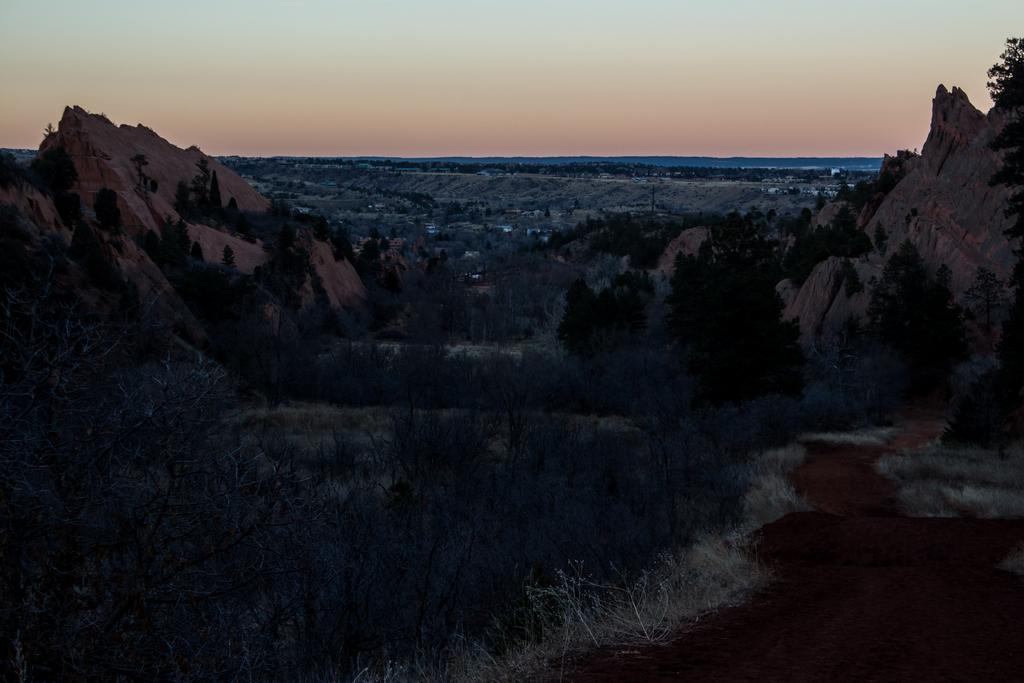What type of vegetation can be seen in the image? There are trees in the image. What geographical features are present on either side of the image? There are two small hills on either side of the image. What is visible in the background of the image? The sky is visible in the background of the image. What is the color of the sky in the image? The sky has an orange color in the image. Where are the chairs located in the image? There are no chairs present in the image. What type of zipper can be seen on the trees in the image? There are no zippers present on the trees in the image. 